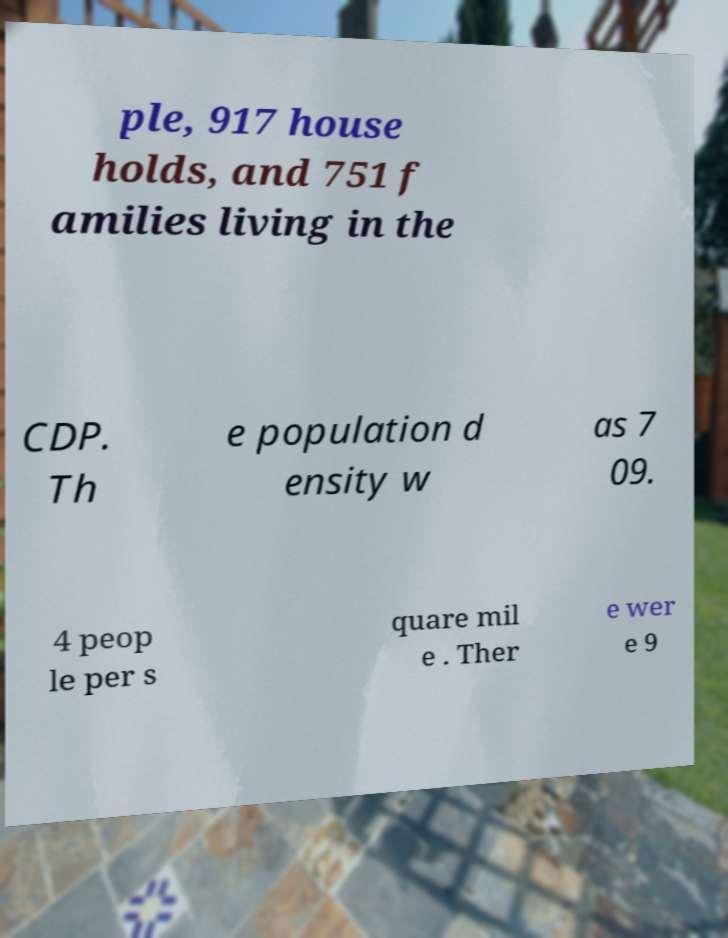Can you read and provide the text displayed in the image?This photo seems to have some interesting text. Can you extract and type it out for me? ple, 917 house holds, and 751 f amilies living in the CDP. Th e population d ensity w as 7 09. 4 peop le per s quare mil e . Ther e wer e 9 